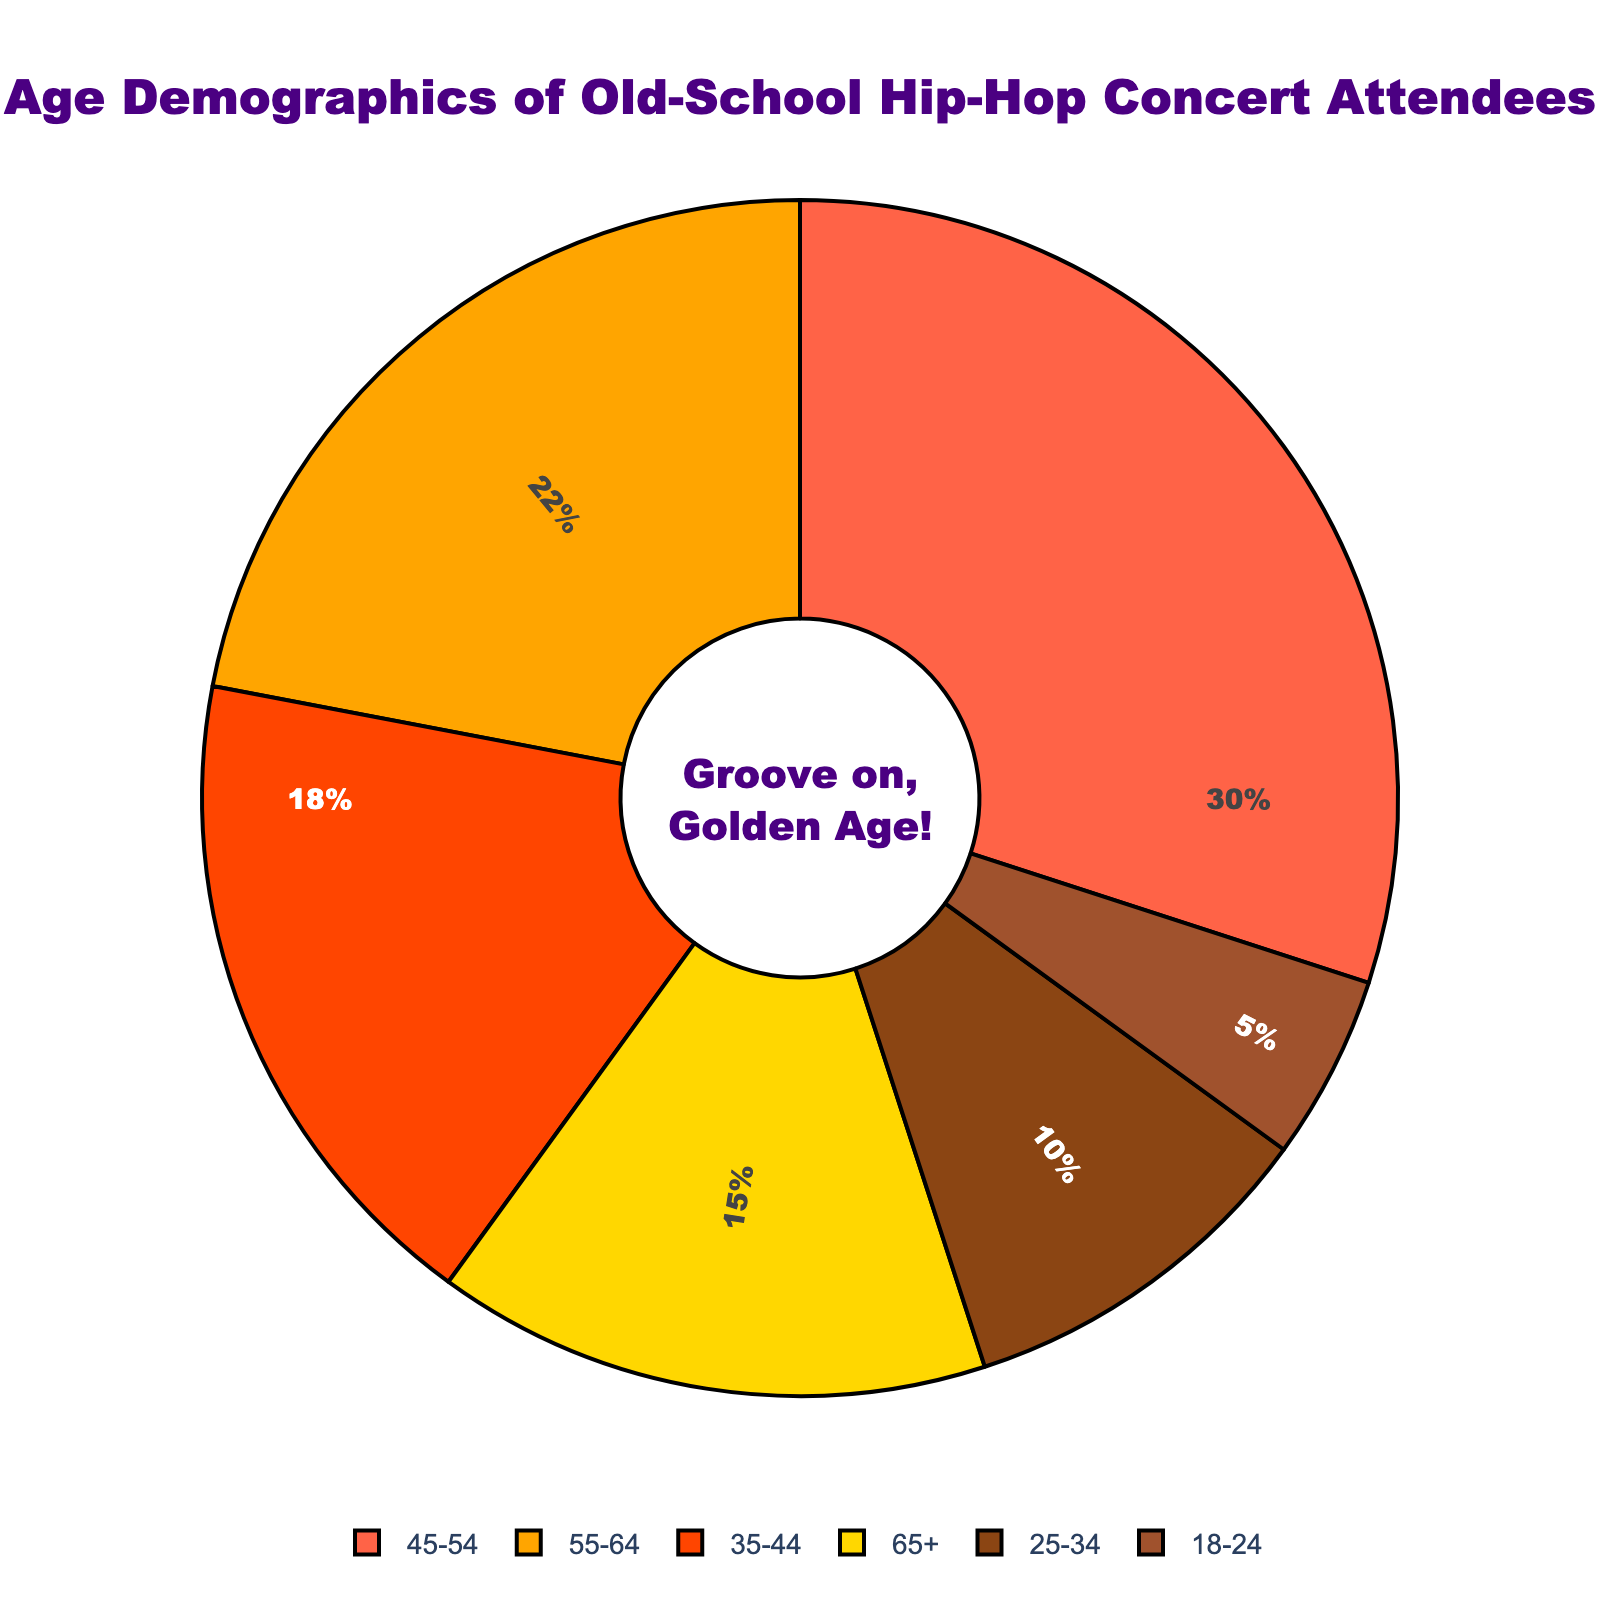What age group has the highest percentage of attendees? By observing the pie chart, we see the largest segment, marked 30%, is labeled "45-54."
Answer: 45-54 Which age groups have more than 20% of the attendees? Reviewing the chart, the age groups with percentages over 20% are "45-54" with 30% and "55-64" with 22%.
Answer: 45-54, 55-64 What is the combined percentage of attendees aged 35-44 and 25-34? Adding the percentages for the "35-44" and "25-34" groups, we get 18% + 10%, resulting in 28%.
Answer: 28% Which age group has the lowest percentage of attendees? The smallest segment, marked 5%, is labeled "18-24."
Answer: 18-24 How much more popular are the 45-54 age group attendees compared to the 18-24 age group attendees? The pie chart shows "45-54" with 30% and "18-24" with 5%. Subtracting these gives 30% - 5%, which equals 25%.
Answer: 25% Which has a bigger percentage, the 55-64 age group or the 65+ age group? Observing the chart, the 55-64 age group at 22% is larger than the 65+ age group at 15%.
Answer: 55-64 What proportion of the total attendance do the 45-54, 55-64, and 65+ age groups collectively account for? Summing the percentages for these age groups ("45-54": 30%, "55-64": 22%, "65+": 15%), we get 30% + 22% + 15% = 67%.
Answer: 67% What percentage of attendees are younger than 35? Summing the percentages for "18-24" (5%) and "25-34" (10%), we get 5% + 10%, which equals 15%.
Answer: 15% Is the 35-44 age group larger than the 25-34 age group in terms of percentage? By comparing the chart, the 35-44 age group with 18% is indeed larger than the 25-34 age group with 10%.
Answer: Yes What percentage of attendees are older than 54? Adding the percentages for "55-64" (22%) and "65+" (15%), we get 22% + 15% = 37%.
Answer: 37% 